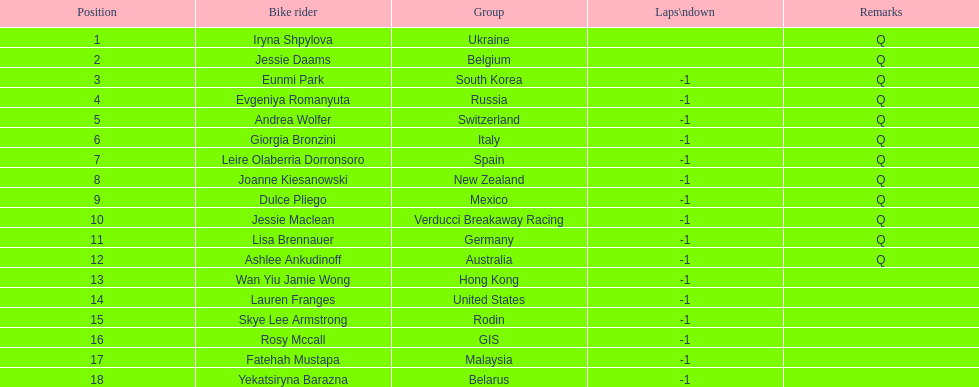Who is the last cyclist listed? Yekatsiryna Barazna. 